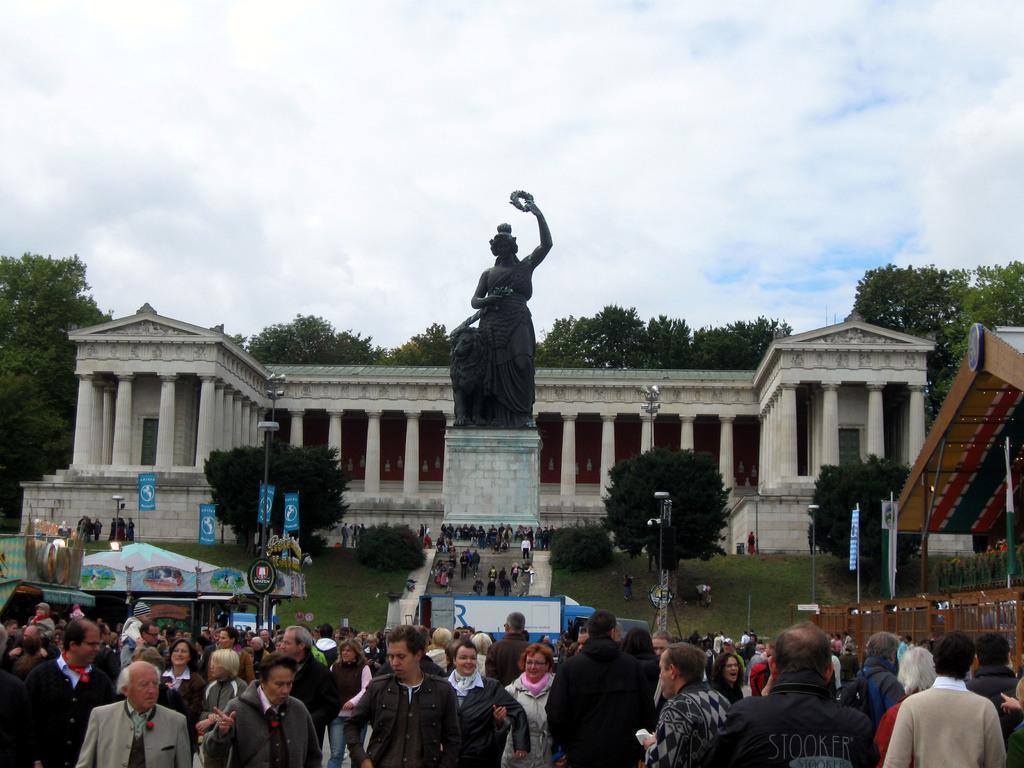In one or two sentences, can you explain what this image depicts? This is an historical places. Here we can see pillars, sculpture, plants, trees, grass, shed, store, flags, light poles and people. Background there are trees. Sky is cloudy.   